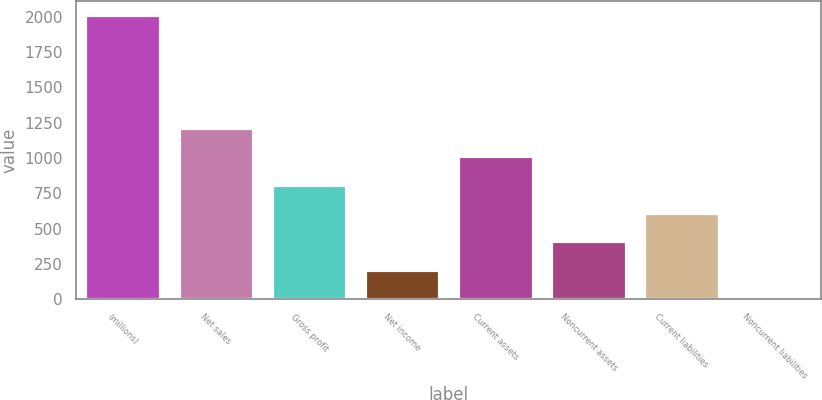Convert chart. <chart><loc_0><loc_0><loc_500><loc_500><bar_chart><fcel>(millions)<fcel>Net sales<fcel>Gross profit<fcel>Net income<fcel>Current assets<fcel>Noncurrent assets<fcel>Current liabilities<fcel>Noncurrent liabilities<nl><fcel>2015<fcel>1212.24<fcel>810.86<fcel>208.79<fcel>1011.55<fcel>409.48<fcel>610.17<fcel>8.1<nl></chart> 